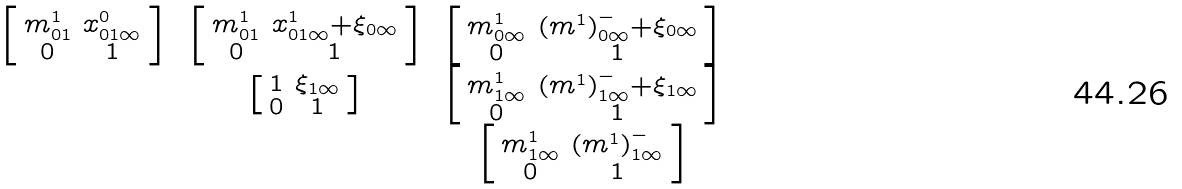<formula> <loc_0><loc_0><loc_500><loc_500>\begin{matrix} \left [ \begin{smallmatrix} m ^ { 1 } _ { 0 1 } & x ^ { 0 } _ { 0 1 \infty } \\ 0 & 1 \end{smallmatrix} \right ] & \left [ \begin{smallmatrix} m ^ { 1 } _ { 0 1 } & x ^ { 1 } _ { 0 1 \infty } + \xi _ { 0 \infty } \\ 0 & 1 \end{smallmatrix} \right ] & \left [ \begin{smallmatrix} m ^ { 1 } _ { 0 \infty } & ( m ^ { 1 } ) ^ { - } _ { 0 \infty } + \xi _ { 0 \infty } \\ 0 & 1 \end{smallmatrix} \right ] \\ & \left [ \begin{smallmatrix} 1 & \xi _ { 1 \infty } \\ 0 & 1 \end{smallmatrix} \right ] & \left [ \begin{smallmatrix} m ^ { 1 } _ { 1 \infty } & ( m ^ { 1 } ) ^ { - } _ { 1 \infty } + \xi _ { 1 \infty } \\ 0 & 1 \end{smallmatrix} \right ] \\ & & \left [ \begin{smallmatrix} m ^ { 1 } _ { 1 \infty } & ( m ^ { 1 } ) ^ { - } _ { 1 \infty } \\ 0 & 1 \end{smallmatrix} \right ] \\ \end{matrix}</formula> 